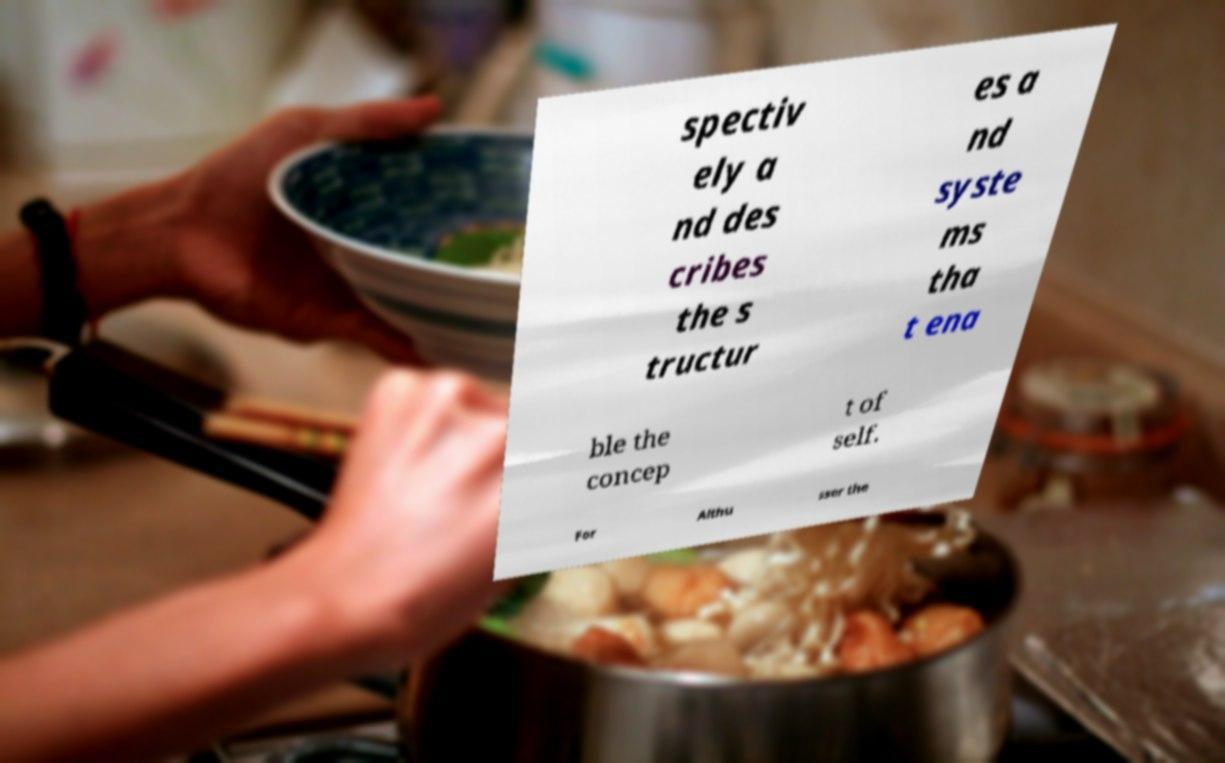I need the written content from this picture converted into text. Can you do that? spectiv ely a nd des cribes the s tructur es a nd syste ms tha t ena ble the concep t of self. For Althu sser the 